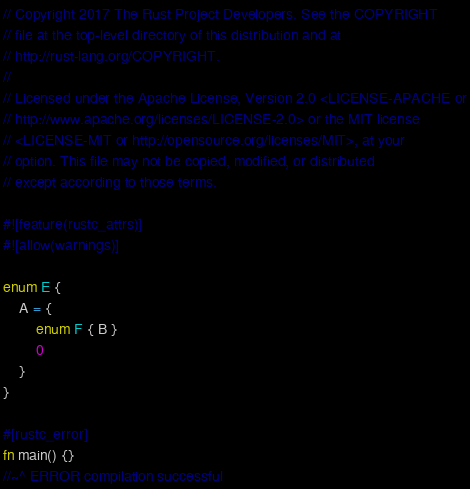<code> <loc_0><loc_0><loc_500><loc_500><_Rust_>// Copyright 2017 The Rust Project Developers. See the COPYRIGHT
// file at the top-level directory of this distribution and at
// http://rust-lang.org/COPYRIGHT.
//
// Licensed under the Apache License, Version 2.0 <LICENSE-APACHE or
// http://www.apache.org/licenses/LICENSE-2.0> or the MIT license
// <LICENSE-MIT or http://opensource.org/licenses/MIT>, at your
// option. This file may not be copied, modified, or distributed
// except according to those terms.

#![feature(rustc_attrs)]
#![allow(warnings)]

enum E {
    A = {
        enum F { B }
        0
    }
}

#[rustc_error]
fn main() {}
//~^ ERROR compilation successful

</code> 